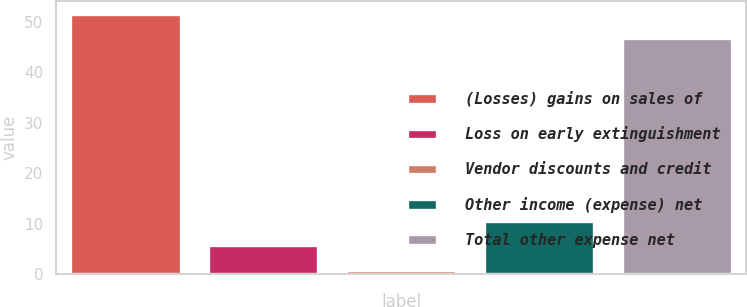<chart> <loc_0><loc_0><loc_500><loc_500><bar_chart><fcel>(Losses) gains on sales of<fcel>Loss on early extinguishment<fcel>Vendor discounts and credit<fcel>Other income (expense) net<fcel>Total other expense net<nl><fcel>51.58<fcel>5.68<fcel>0.8<fcel>10.56<fcel>46.7<nl></chart> 